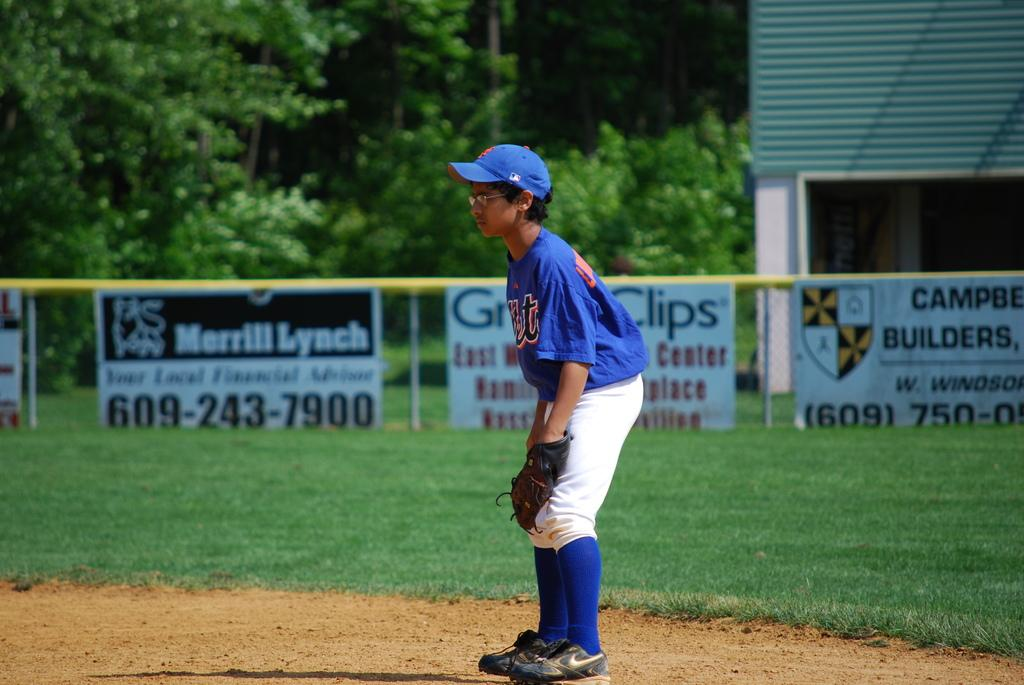<image>
Give a short and clear explanation of the subsequent image. An ad for Merrill Lynch is hanging against the fence among other ads 